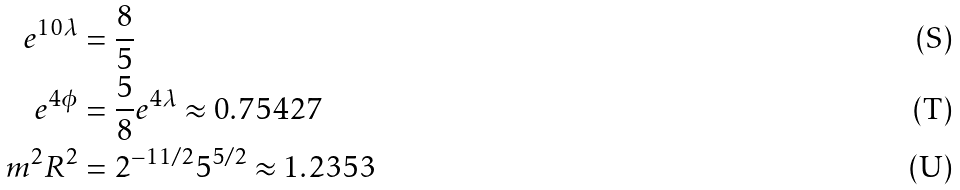<formula> <loc_0><loc_0><loc_500><loc_500>e ^ { 1 0 \lambda } & = \frac { 8 } { 5 } \\ e ^ { 4 \phi } & = \frac { 5 } { 8 } e ^ { 4 \lambda } \approx 0 . 7 5 4 2 7 \\ m ^ { 2 } R ^ { 2 } & = 2 ^ { - 1 1 / 2 } 5 ^ { 5 / 2 } \approx 1 . 2 3 5 3</formula> 